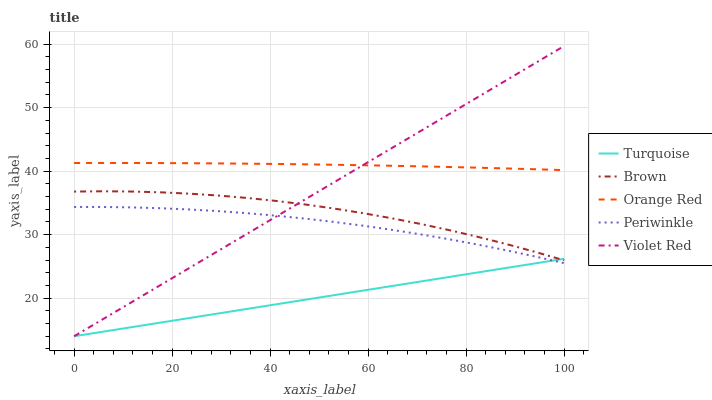Does Turquoise have the minimum area under the curve?
Answer yes or no. Yes. Does Orange Red have the maximum area under the curve?
Answer yes or no. Yes. Does Periwinkle have the minimum area under the curve?
Answer yes or no. No. Does Periwinkle have the maximum area under the curve?
Answer yes or no. No. Is Turquoise the smoothest?
Answer yes or no. Yes. Is Brown the roughest?
Answer yes or no. Yes. Is Periwinkle the smoothest?
Answer yes or no. No. Is Periwinkle the roughest?
Answer yes or no. No. Does Turquoise have the lowest value?
Answer yes or no. Yes. Does Periwinkle have the lowest value?
Answer yes or no. No. Does Violet Red have the highest value?
Answer yes or no. Yes. Does Periwinkle have the highest value?
Answer yes or no. No. Is Brown less than Orange Red?
Answer yes or no. Yes. Is Orange Red greater than Periwinkle?
Answer yes or no. Yes. Does Turquoise intersect Brown?
Answer yes or no. Yes. Is Turquoise less than Brown?
Answer yes or no. No. Is Turquoise greater than Brown?
Answer yes or no. No. Does Brown intersect Orange Red?
Answer yes or no. No. 